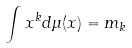<formula> <loc_0><loc_0><loc_500><loc_500>\int x ^ { k } d \mu ( x ) = m _ { k }</formula> 